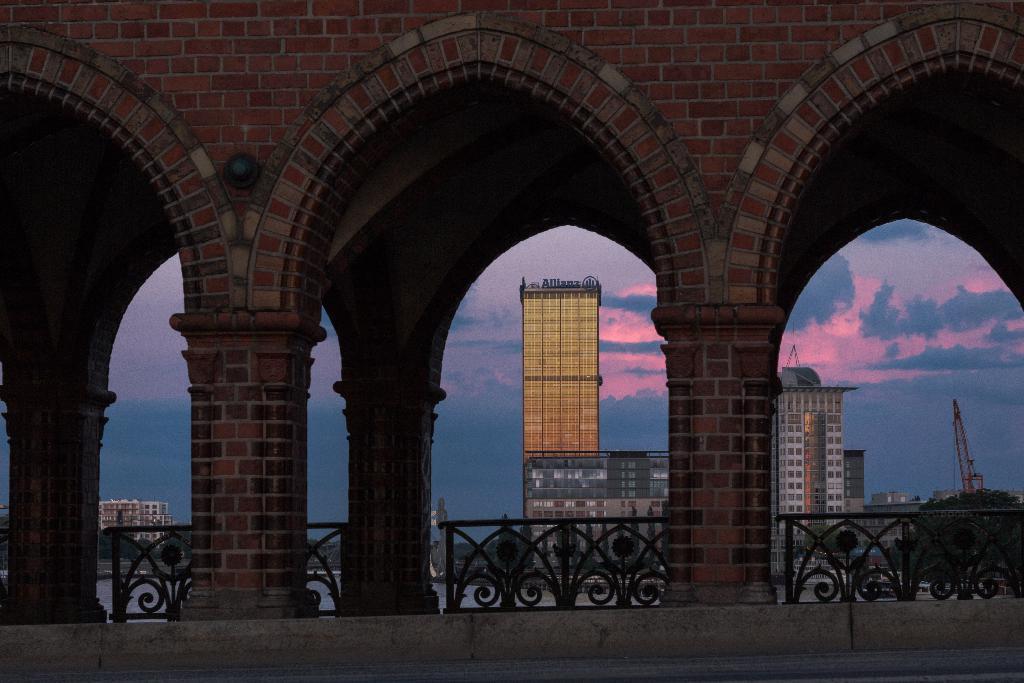Describe this image in one or two sentences. In this image I can see a wall, pillars, fence, buildings, water, vehicles on the road and the sky. This image is taken may be on the road. 